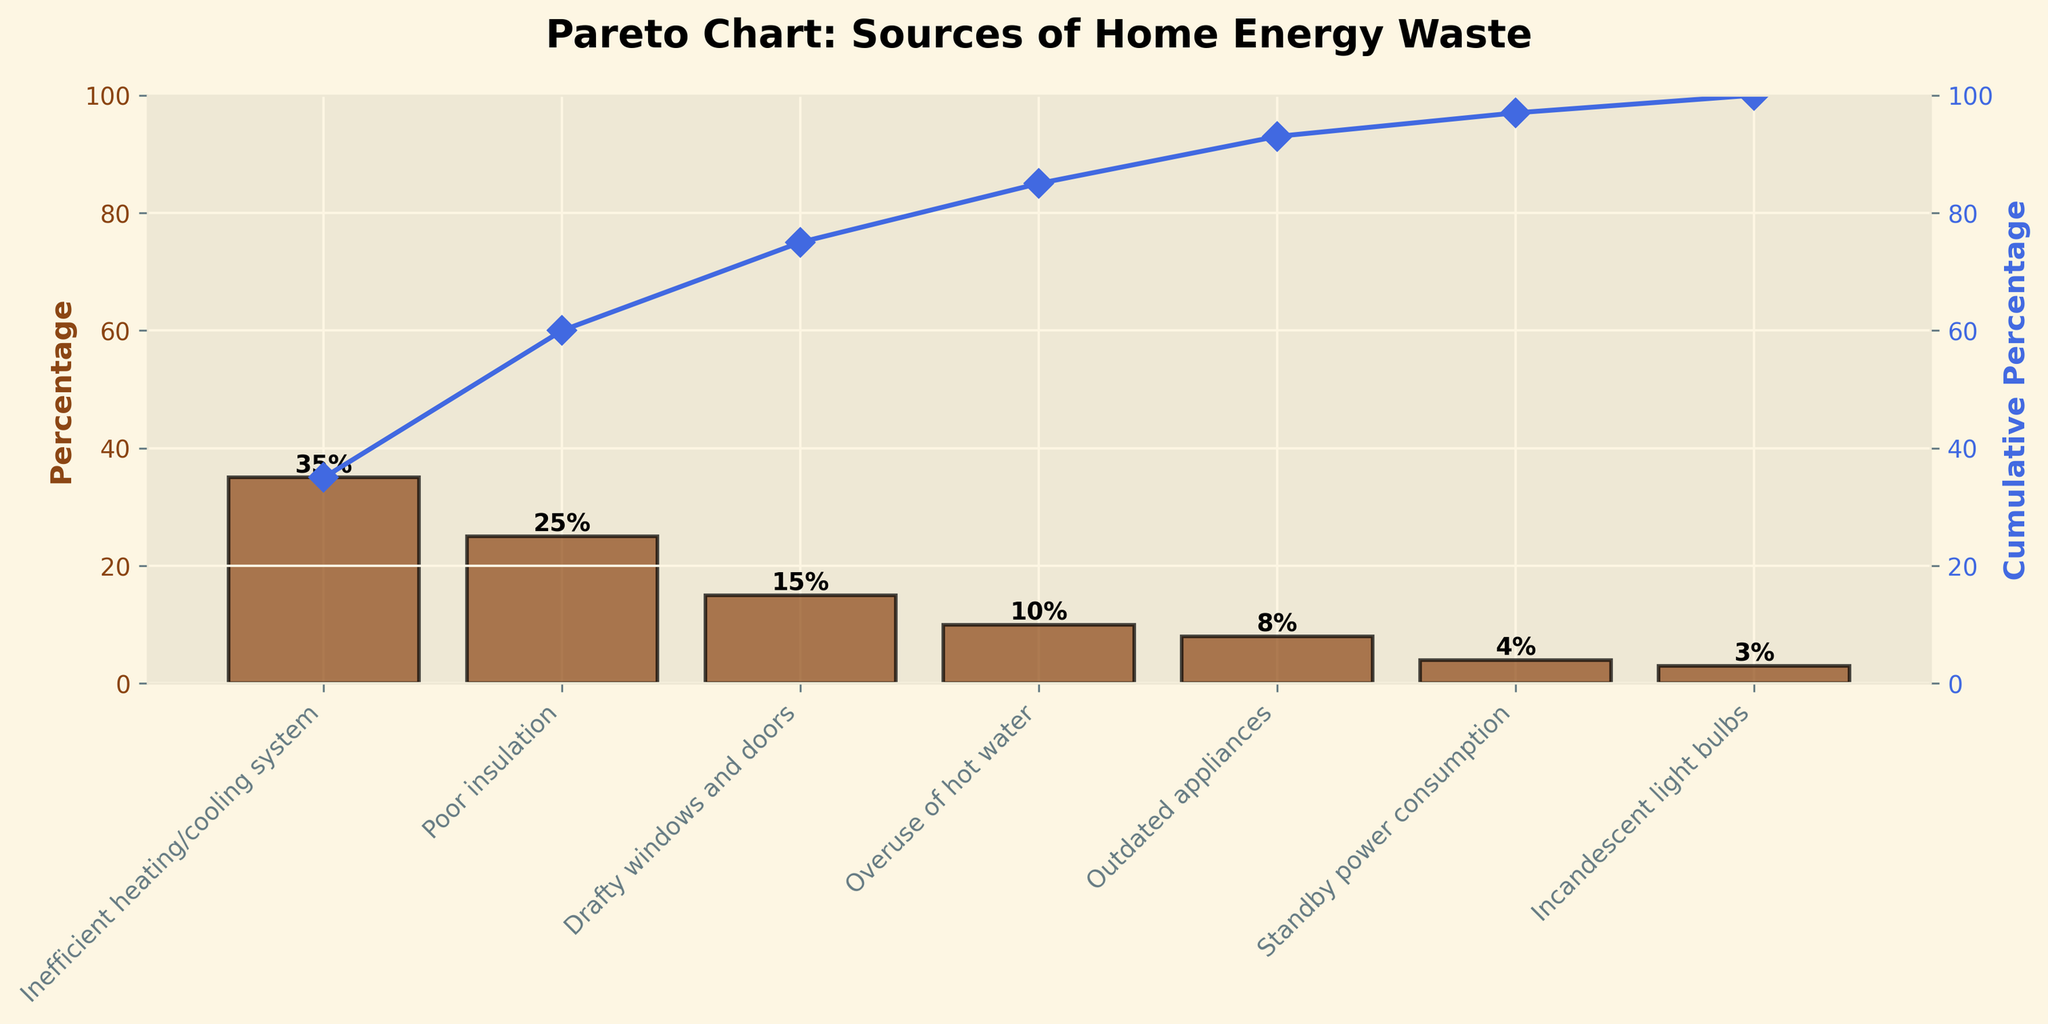What's the title of the chart? The title of the chart is the text displayed at the top of the figure.
Answer: Pareto Chart: Sources of Home Energy Waste What is the source with the highest percentage of home energy waste? Look for the tallest bar in the bar chart.
Answer: Inefficient heating/cooling system What percentage of home energy waste is caused by poor insulation? Find the height of the bar labeled "Poor insulation".
Answer: 25% Which sources of home energy waste contribute more than 20%? Identify bars with heights greater than 20%.
Answer: Inefficient heating/cooling system and Poor insulation How many sources are listed in the chart? Count the number of bars in the bar chart.
Answer: 7 What is the cumulative percentage after the first three sources? Add the percentages of the first three bars: 35% + 25% + 15%.
Answer: 75% Which source has a lower percentage of home energy waste: Outdated appliances or Standby power consumption? Compare the heights of the bars labeled "Outdated appliances" and "Standby power consumption".
Answer: Standby power consumption What color is used for the cumulative percentage line? Identify the color of the line running through the points on the secondary axis.
Answer: Blue What is the cumulative percentage when outdated appliances are included? Sum up the percentages up to and including "Outdated appliances": 35% + 25% + 15% + 10% + 8%.
Answer: 93% What is the combined percentage of energy waste from overuse of hot water and incandescent light bulbs? Add the percentages of the two sources: 10% + 3%.
Answer: 13% 